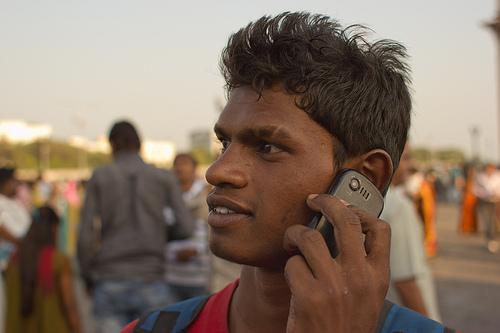How many people can be seen holding phones?
Give a very brief answer. 1. How many people can be seen wearing green dresses?
Give a very brief answer. 1. How many people are in the background on the left side of the man's head?
Give a very brief answer. 4. How many shaved lines are in the man's right eyebrow?
Give a very brief answer. 2. 